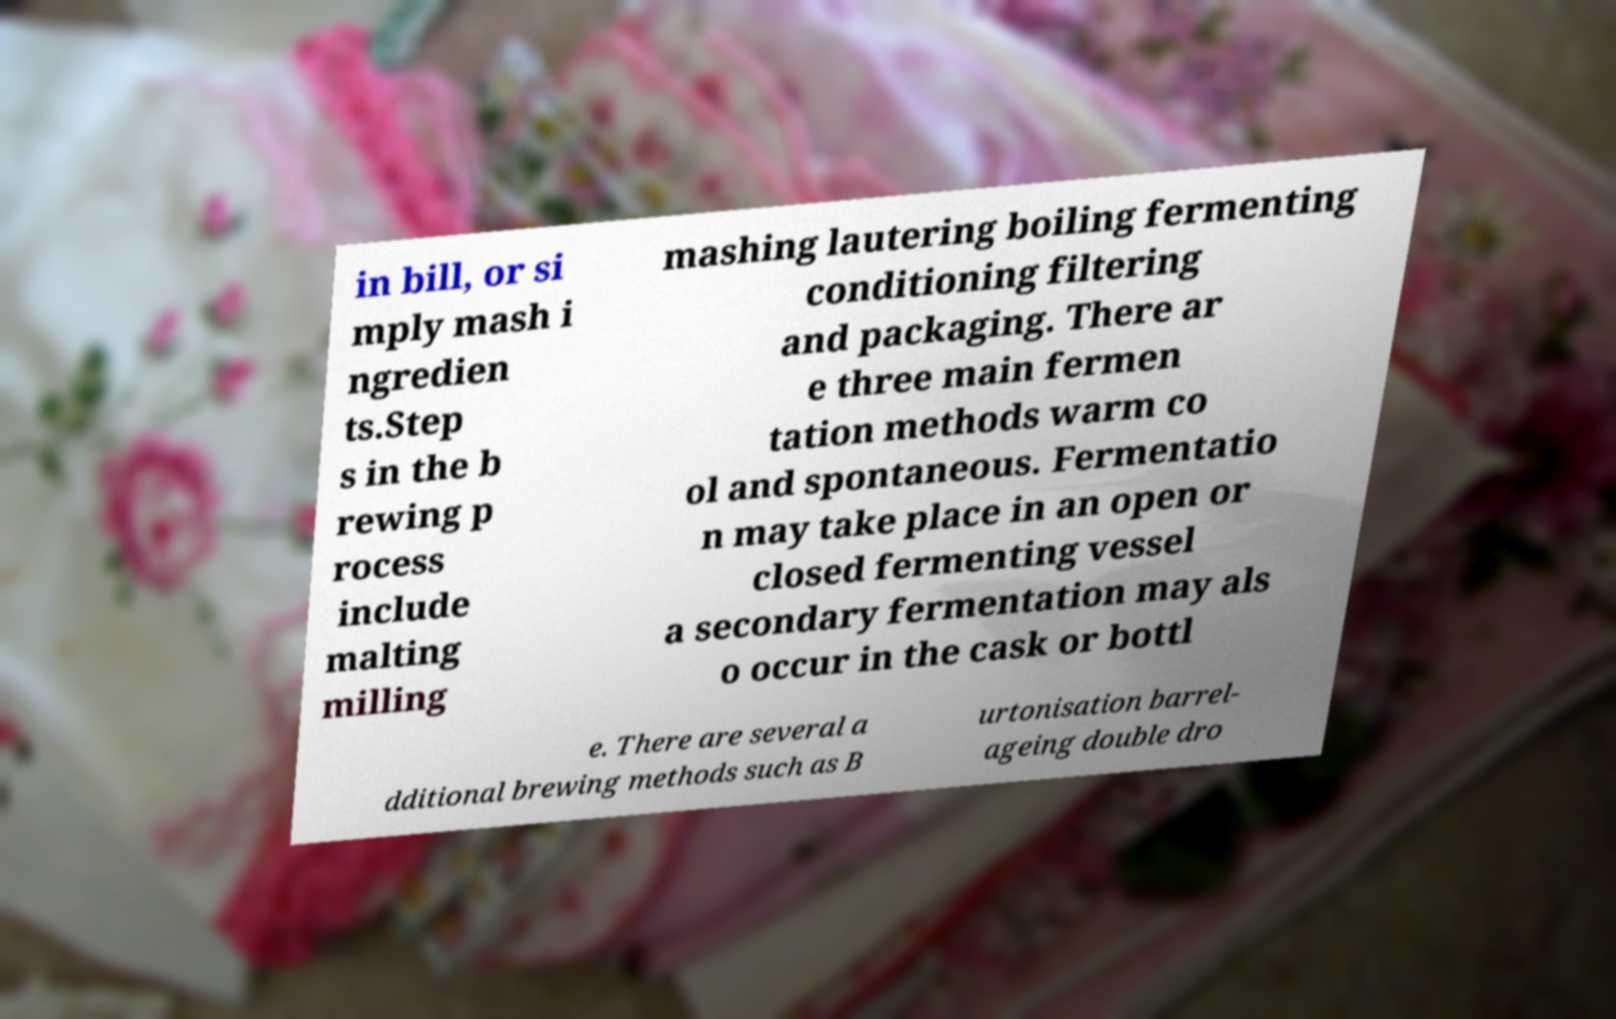For documentation purposes, I need the text within this image transcribed. Could you provide that? in bill, or si mply mash i ngredien ts.Step s in the b rewing p rocess include malting milling mashing lautering boiling fermenting conditioning filtering and packaging. There ar e three main fermen tation methods warm co ol and spontaneous. Fermentatio n may take place in an open or closed fermenting vessel a secondary fermentation may als o occur in the cask or bottl e. There are several a dditional brewing methods such as B urtonisation barrel- ageing double dro 